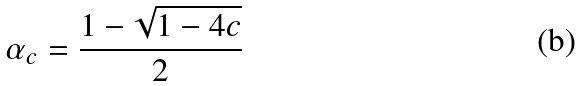Convert formula to latex. <formula><loc_0><loc_0><loc_500><loc_500>\alpha _ { c } = \frac { 1 - \sqrt { 1 - 4 c } } { 2 }</formula> 